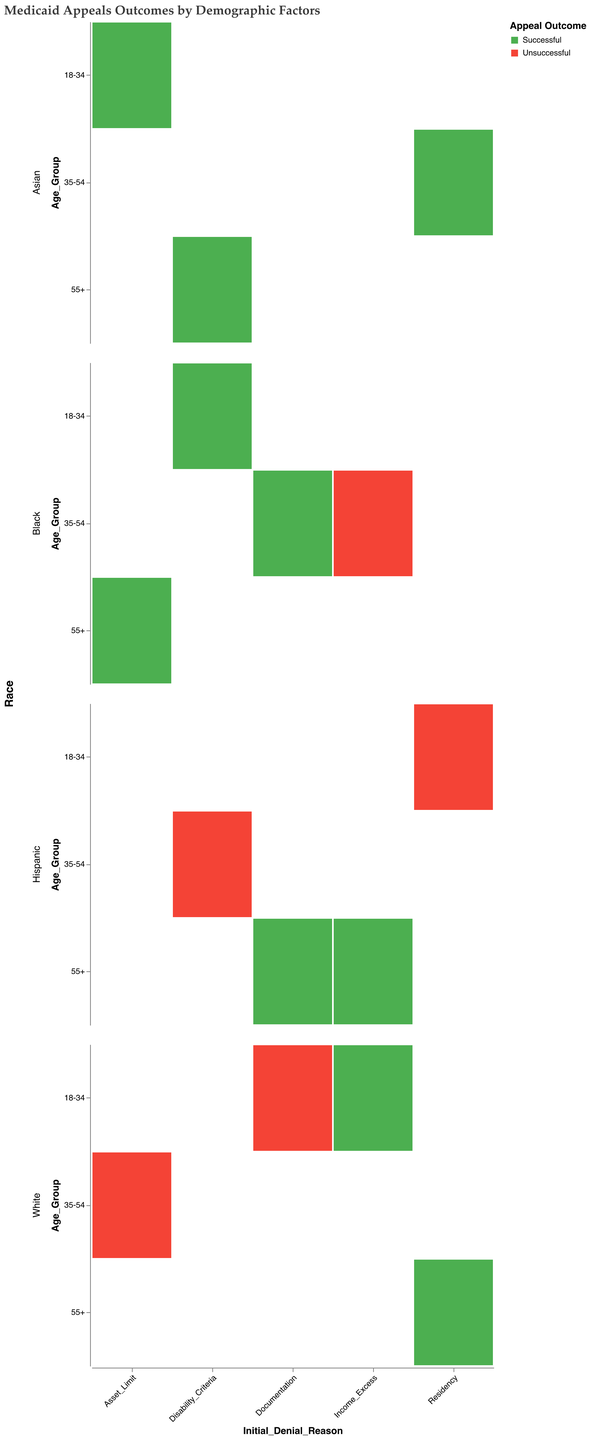What is the title of the plot? The title is usually displayed at the top of the plot in bold and is meant to summarize what the plot is about.
Answer: Medicaid Appeals Outcomes by Demographic Factors What are the color codes used to represent successful and unsuccessful appeal outcomes? The figure uses two distinct colors to differentiate between successful and unsuccessful outcomes. Green (#4caf50) represents successful outcomes, while Red (#f44336) represents unsuccessful outcomes.
Answer: Green for Successful, Red for Unsuccessful How many racial groups are represented in the plot? In the plot, the "Race" field is encoded in rows, and each row represents a different racial group. By counting these rows, we can determine the number of racial groups.
Answer: Four Which age group has the most successful appeals for Asset Limit initial denial across all races? To answer this, you need to look at the "Asset Limit" column and count the successful outcomes (green) across all age groups (18-34, 35-54, 55+).
Answer: 18-34 and 55+ Which racial group has the highest number of successful Medicaid appeals for initial denial due to Disability Criteria? Focus on the row for "Disability Criteria" and count the number of successful outcomes (green) for each racial group.
Answer: Asian and Black For the Documentation initial denial reason, is there a particular age group that stands out as more successful or unsuccessful in their appeals? Look at the "Documentation" column and compare the number of successful (green) and unsuccessful (red) appeals across the different age groups.
Answer: 35-54 and 55+ are successful, 18-34 is unsuccessful Compare the successful appeal outcomes for Residency initial denial between the age groups for Hispanic individuals. Focus on the Hispanic row within the "Residency" column and count the number of successful outcomes for each age group.
Answer: No successful appeals for any age group Which demographic factor appears to have the least successful appeals when the initial denial reason is Documentation? Look at the "Documentation" column and identify which demographic factors (age group/race) have fewer successful (green) appeals.
Answer: 18-34, White Are there any age groups that have successful appeal outcomes for every initial denial reason? You need to check each age group to see if they have a green (successful) mark in each column of Initial Denial Reason (Income Excess, Asset Limit, Residency, Disability Criteria, Documentation).
Answer: No 